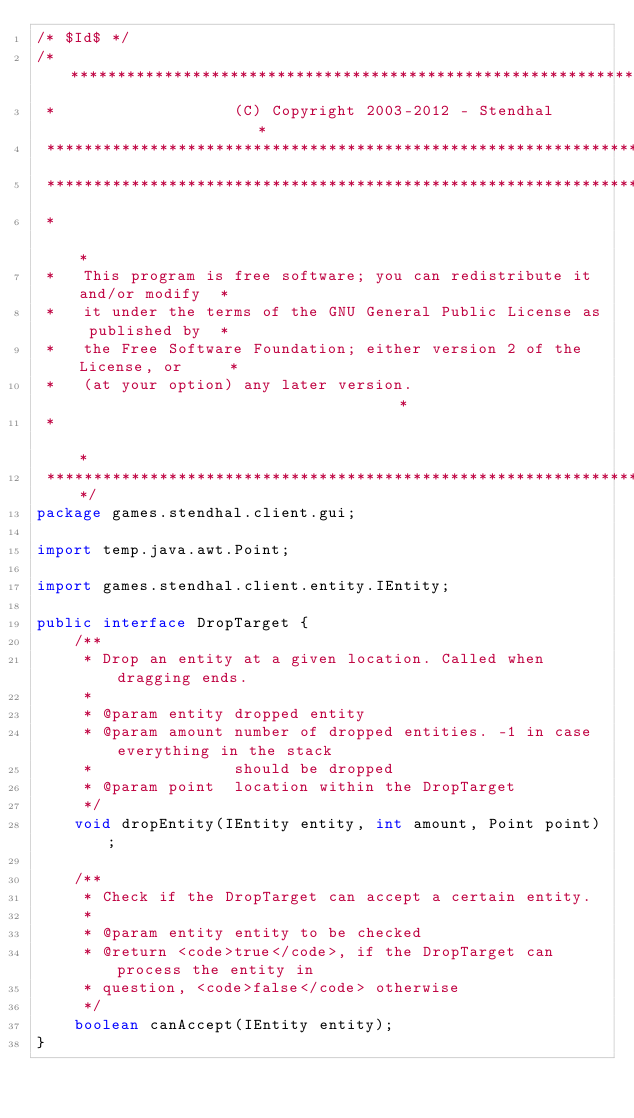<code> <loc_0><loc_0><loc_500><loc_500><_Java_>/* $Id$ */
/***************************************************************************
 *                   (C) Copyright 2003-2012 - Stendhal                    *
 ***************************************************************************
 ***************************************************************************
 *                                                                         *
 *   This program is free software; you can redistribute it and/or modify  *
 *   it under the terms of the GNU General Public License as published by  *
 *   the Free Software Foundation; either version 2 of the License, or     *
 *   (at your option) any later version.                                   *
 *                                                                         *
 ***************************************************************************/
package games.stendhal.client.gui;

import temp.java.awt.Point;

import games.stendhal.client.entity.IEntity;

public interface DropTarget {
    /**
     * Drop an entity at a given location. Called when dragging ends.
     *
     * @param entity dropped entity
     * @param amount number of dropped entities. -1 in case everything in the stack
     *               should be dropped
     * @param point  location within the DropTarget
     */
    void dropEntity(IEntity entity, int amount, Point point);

    /**
     * Check if the DropTarget can accept a certain entity.
     *
     * @param entity entity to be checked
     * @return <code>true</code>, if the DropTarget can process the entity in
     * question, <code>false</code> otherwise
     */
    boolean canAccept(IEntity entity);
}
</code> 